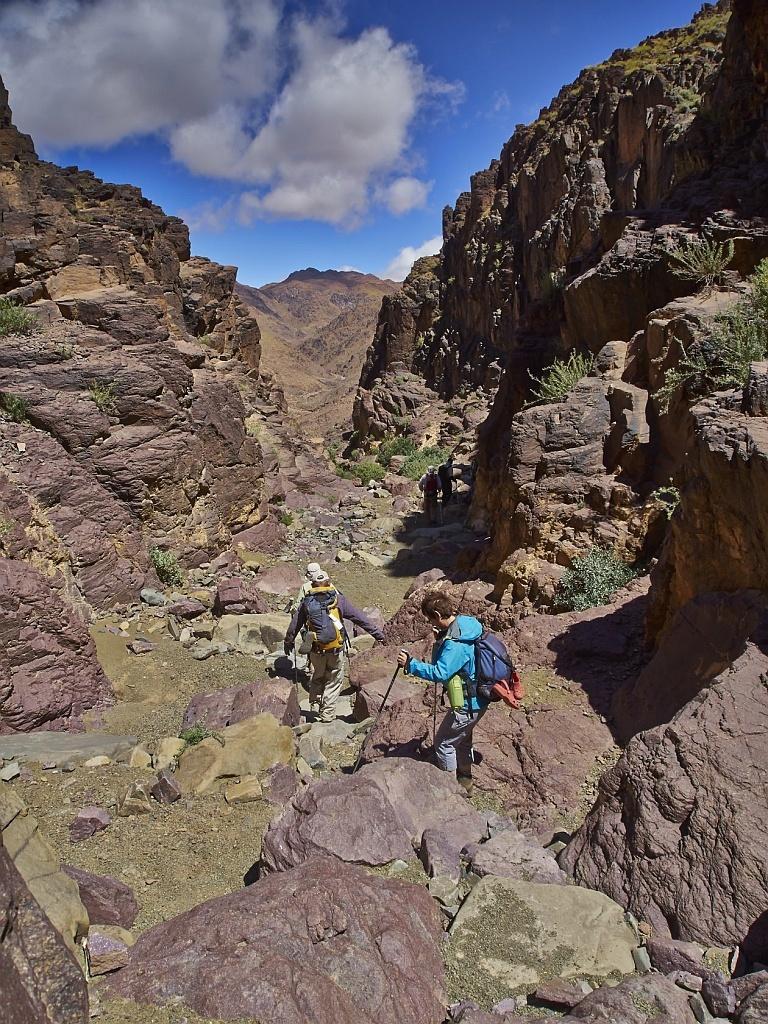In one or two sentences, can you explain what this image depicts? In this image we can see the mountains. And we can see the persons walking on the ground and holding sticks. There are plants and cloudy sky in the background. 